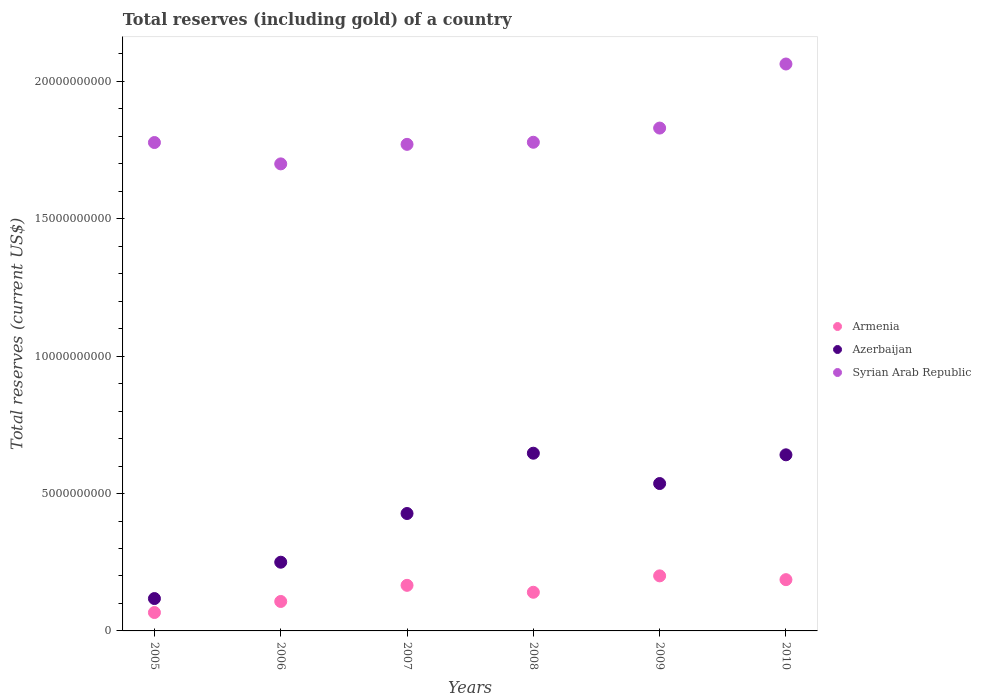Is the number of dotlines equal to the number of legend labels?
Provide a succinct answer. Yes. What is the total reserves (including gold) in Armenia in 2008?
Your answer should be very brief. 1.41e+09. Across all years, what is the maximum total reserves (including gold) in Armenia?
Keep it short and to the point. 2.00e+09. Across all years, what is the minimum total reserves (including gold) in Syrian Arab Republic?
Make the answer very short. 1.70e+1. In which year was the total reserves (including gold) in Azerbaijan maximum?
Offer a terse response. 2008. In which year was the total reserves (including gold) in Armenia minimum?
Provide a succinct answer. 2005. What is the total total reserves (including gold) in Azerbaijan in the graph?
Keep it short and to the point. 2.62e+1. What is the difference between the total reserves (including gold) in Armenia in 2005 and that in 2006?
Provide a short and direct response. -4.02e+08. What is the difference between the total reserves (including gold) in Syrian Arab Republic in 2006 and the total reserves (including gold) in Armenia in 2005?
Keep it short and to the point. 1.63e+1. What is the average total reserves (including gold) in Azerbaijan per year?
Make the answer very short. 4.37e+09. In the year 2008, what is the difference between the total reserves (including gold) in Armenia and total reserves (including gold) in Syrian Arab Republic?
Keep it short and to the point. -1.64e+1. In how many years, is the total reserves (including gold) in Armenia greater than 7000000000 US$?
Ensure brevity in your answer.  0. What is the ratio of the total reserves (including gold) in Azerbaijan in 2005 to that in 2008?
Offer a very short reply. 0.18. Is the total reserves (including gold) in Armenia in 2007 less than that in 2009?
Ensure brevity in your answer.  Yes. Is the difference between the total reserves (including gold) in Armenia in 2006 and 2010 greater than the difference between the total reserves (including gold) in Syrian Arab Republic in 2006 and 2010?
Your answer should be compact. Yes. What is the difference between the highest and the second highest total reserves (including gold) in Armenia?
Provide a short and direct response. 1.38e+08. What is the difference between the highest and the lowest total reserves (including gold) in Armenia?
Keep it short and to the point. 1.33e+09. Does the total reserves (including gold) in Syrian Arab Republic monotonically increase over the years?
Keep it short and to the point. No. What is the difference between two consecutive major ticks on the Y-axis?
Keep it short and to the point. 5.00e+09. Are the values on the major ticks of Y-axis written in scientific E-notation?
Keep it short and to the point. No. How are the legend labels stacked?
Your answer should be very brief. Vertical. What is the title of the graph?
Ensure brevity in your answer.  Total reserves (including gold) of a country. What is the label or title of the Y-axis?
Your answer should be very brief. Total reserves (current US$). What is the Total reserves (current US$) of Armenia in 2005?
Make the answer very short. 6.69e+08. What is the Total reserves (current US$) of Azerbaijan in 2005?
Provide a short and direct response. 1.18e+09. What is the Total reserves (current US$) in Syrian Arab Republic in 2005?
Keep it short and to the point. 1.78e+1. What is the Total reserves (current US$) of Armenia in 2006?
Offer a terse response. 1.07e+09. What is the Total reserves (current US$) of Azerbaijan in 2006?
Your response must be concise. 2.50e+09. What is the Total reserves (current US$) of Syrian Arab Republic in 2006?
Provide a succinct answer. 1.70e+1. What is the Total reserves (current US$) of Armenia in 2007?
Your answer should be very brief. 1.66e+09. What is the Total reserves (current US$) of Azerbaijan in 2007?
Your response must be concise. 4.27e+09. What is the Total reserves (current US$) in Syrian Arab Republic in 2007?
Your response must be concise. 1.77e+1. What is the Total reserves (current US$) of Armenia in 2008?
Offer a very short reply. 1.41e+09. What is the Total reserves (current US$) of Azerbaijan in 2008?
Provide a short and direct response. 6.47e+09. What is the Total reserves (current US$) of Syrian Arab Republic in 2008?
Your answer should be very brief. 1.78e+1. What is the Total reserves (current US$) of Armenia in 2009?
Offer a terse response. 2.00e+09. What is the Total reserves (current US$) in Azerbaijan in 2009?
Offer a very short reply. 5.36e+09. What is the Total reserves (current US$) in Syrian Arab Republic in 2009?
Provide a short and direct response. 1.83e+1. What is the Total reserves (current US$) of Armenia in 2010?
Offer a very short reply. 1.87e+09. What is the Total reserves (current US$) in Azerbaijan in 2010?
Provide a short and direct response. 6.41e+09. What is the Total reserves (current US$) of Syrian Arab Republic in 2010?
Provide a short and direct response. 2.06e+1. Across all years, what is the maximum Total reserves (current US$) in Armenia?
Provide a succinct answer. 2.00e+09. Across all years, what is the maximum Total reserves (current US$) of Azerbaijan?
Offer a very short reply. 6.47e+09. Across all years, what is the maximum Total reserves (current US$) in Syrian Arab Republic?
Keep it short and to the point. 2.06e+1. Across all years, what is the minimum Total reserves (current US$) in Armenia?
Give a very brief answer. 6.69e+08. Across all years, what is the minimum Total reserves (current US$) in Azerbaijan?
Give a very brief answer. 1.18e+09. Across all years, what is the minimum Total reserves (current US$) in Syrian Arab Republic?
Keep it short and to the point. 1.70e+1. What is the total Total reserves (current US$) in Armenia in the graph?
Your answer should be compact. 8.68e+09. What is the total Total reserves (current US$) of Azerbaijan in the graph?
Keep it short and to the point. 2.62e+1. What is the total Total reserves (current US$) in Syrian Arab Republic in the graph?
Keep it short and to the point. 1.09e+11. What is the difference between the Total reserves (current US$) in Armenia in 2005 and that in 2006?
Provide a succinct answer. -4.02e+08. What is the difference between the Total reserves (current US$) in Azerbaijan in 2005 and that in 2006?
Your answer should be compact. -1.32e+09. What is the difference between the Total reserves (current US$) of Syrian Arab Republic in 2005 and that in 2006?
Offer a very short reply. 7.77e+08. What is the difference between the Total reserves (current US$) of Armenia in 2005 and that in 2007?
Provide a short and direct response. -9.90e+08. What is the difference between the Total reserves (current US$) in Azerbaijan in 2005 and that in 2007?
Your answer should be very brief. -3.10e+09. What is the difference between the Total reserves (current US$) in Syrian Arab Republic in 2005 and that in 2007?
Give a very brief answer. 6.67e+07. What is the difference between the Total reserves (current US$) in Armenia in 2005 and that in 2008?
Offer a very short reply. -7.37e+08. What is the difference between the Total reserves (current US$) of Azerbaijan in 2005 and that in 2008?
Ensure brevity in your answer.  -5.29e+09. What is the difference between the Total reserves (current US$) in Syrian Arab Republic in 2005 and that in 2008?
Provide a succinct answer. -9.60e+06. What is the difference between the Total reserves (current US$) of Armenia in 2005 and that in 2009?
Your answer should be very brief. -1.33e+09. What is the difference between the Total reserves (current US$) of Azerbaijan in 2005 and that in 2009?
Provide a succinct answer. -4.19e+09. What is the difference between the Total reserves (current US$) in Syrian Arab Republic in 2005 and that in 2009?
Ensure brevity in your answer.  -5.26e+08. What is the difference between the Total reserves (current US$) of Armenia in 2005 and that in 2010?
Keep it short and to the point. -1.20e+09. What is the difference between the Total reserves (current US$) in Azerbaijan in 2005 and that in 2010?
Give a very brief answer. -5.23e+09. What is the difference between the Total reserves (current US$) of Syrian Arab Republic in 2005 and that in 2010?
Ensure brevity in your answer.  -2.86e+09. What is the difference between the Total reserves (current US$) of Armenia in 2006 and that in 2007?
Give a very brief answer. -5.87e+08. What is the difference between the Total reserves (current US$) in Azerbaijan in 2006 and that in 2007?
Your answer should be very brief. -1.77e+09. What is the difference between the Total reserves (current US$) in Syrian Arab Republic in 2006 and that in 2007?
Ensure brevity in your answer.  -7.11e+08. What is the difference between the Total reserves (current US$) of Armenia in 2006 and that in 2008?
Provide a short and direct response. -3.35e+08. What is the difference between the Total reserves (current US$) of Azerbaijan in 2006 and that in 2008?
Make the answer very short. -3.97e+09. What is the difference between the Total reserves (current US$) of Syrian Arab Republic in 2006 and that in 2008?
Give a very brief answer. -7.87e+08. What is the difference between the Total reserves (current US$) of Armenia in 2006 and that in 2009?
Your answer should be very brief. -9.32e+08. What is the difference between the Total reserves (current US$) of Azerbaijan in 2006 and that in 2009?
Give a very brief answer. -2.86e+09. What is the difference between the Total reserves (current US$) of Syrian Arab Republic in 2006 and that in 2009?
Make the answer very short. -1.30e+09. What is the difference between the Total reserves (current US$) of Armenia in 2006 and that in 2010?
Offer a very short reply. -7.94e+08. What is the difference between the Total reserves (current US$) of Azerbaijan in 2006 and that in 2010?
Offer a terse response. -3.91e+09. What is the difference between the Total reserves (current US$) of Syrian Arab Republic in 2006 and that in 2010?
Your response must be concise. -3.64e+09. What is the difference between the Total reserves (current US$) in Armenia in 2007 and that in 2008?
Keep it short and to the point. 2.52e+08. What is the difference between the Total reserves (current US$) in Azerbaijan in 2007 and that in 2008?
Offer a terse response. -2.19e+09. What is the difference between the Total reserves (current US$) in Syrian Arab Republic in 2007 and that in 2008?
Provide a short and direct response. -7.63e+07. What is the difference between the Total reserves (current US$) in Armenia in 2007 and that in 2009?
Offer a terse response. -3.45e+08. What is the difference between the Total reserves (current US$) of Azerbaijan in 2007 and that in 2009?
Offer a terse response. -1.09e+09. What is the difference between the Total reserves (current US$) in Syrian Arab Republic in 2007 and that in 2009?
Your answer should be compact. -5.93e+08. What is the difference between the Total reserves (current US$) of Armenia in 2007 and that in 2010?
Provide a short and direct response. -2.07e+08. What is the difference between the Total reserves (current US$) of Azerbaijan in 2007 and that in 2010?
Offer a terse response. -2.14e+09. What is the difference between the Total reserves (current US$) of Syrian Arab Republic in 2007 and that in 2010?
Offer a terse response. -2.92e+09. What is the difference between the Total reserves (current US$) of Armenia in 2008 and that in 2009?
Keep it short and to the point. -5.97e+08. What is the difference between the Total reserves (current US$) of Azerbaijan in 2008 and that in 2009?
Provide a succinct answer. 1.10e+09. What is the difference between the Total reserves (current US$) in Syrian Arab Republic in 2008 and that in 2009?
Your answer should be compact. -5.17e+08. What is the difference between the Total reserves (current US$) of Armenia in 2008 and that in 2010?
Offer a terse response. -4.59e+08. What is the difference between the Total reserves (current US$) in Azerbaijan in 2008 and that in 2010?
Offer a very short reply. 5.82e+07. What is the difference between the Total reserves (current US$) of Syrian Arab Republic in 2008 and that in 2010?
Your answer should be very brief. -2.85e+09. What is the difference between the Total reserves (current US$) of Armenia in 2009 and that in 2010?
Provide a short and direct response. 1.38e+08. What is the difference between the Total reserves (current US$) of Azerbaijan in 2009 and that in 2010?
Your answer should be compact. -1.05e+09. What is the difference between the Total reserves (current US$) of Syrian Arab Republic in 2009 and that in 2010?
Provide a short and direct response. -2.33e+09. What is the difference between the Total reserves (current US$) in Armenia in 2005 and the Total reserves (current US$) in Azerbaijan in 2006?
Ensure brevity in your answer.  -1.83e+09. What is the difference between the Total reserves (current US$) of Armenia in 2005 and the Total reserves (current US$) of Syrian Arab Republic in 2006?
Make the answer very short. -1.63e+1. What is the difference between the Total reserves (current US$) of Azerbaijan in 2005 and the Total reserves (current US$) of Syrian Arab Republic in 2006?
Provide a short and direct response. -1.58e+1. What is the difference between the Total reserves (current US$) of Armenia in 2005 and the Total reserves (current US$) of Azerbaijan in 2007?
Provide a succinct answer. -3.60e+09. What is the difference between the Total reserves (current US$) in Armenia in 2005 and the Total reserves (current US$) in Syrian Arab Republic in 2007?
Offer a very short reply. -1.70e+1. What is the difference between the Total reserves (current US$) in Azerbaijan in 2005 and the Total reserves (current US$) in Syrian Arab Republic in 2007?
Offer a terse response. -1.65e+1. What is the difference between the Total reserves (current US$) of Armenia in 2005 and the Total reserves (current US$) of Azerbaijan in 2008?
Provide a succinct answer. -5.80e+09. What is the difference between the Total reserves (current US$) in Armenia in 2005 and the Total reserves (current US$) in Syrian Arab Republic in 2008?
Provide a short and direct response. -1.71e+1. What is the difference between the Total reserves (current US$) in Azerbaijan in 2005 and the Total reserves (current US$) in Syrian Arab Republic in 2008?
Provide a succinct answer. -1.66e+1. What is the difference between the Total reserves (current US$) of Armenia in 2005 and the Total reserves (current US$) of Azerbaijan in 2009?
Keep it short and to the point. -4.69e+09. What is the difference between the Total reserves (current US$) in Armenia in 2005 and the Total reserves (current US$) in Syrian Arab Republic in 2009?
Ensure brevity in your answer.  -1.76e+1. What is the difference between the Total reserves (current US$) of Azerbaijan in 2005 and the Total reserves (current US$) of Syrian Arab Republic in 2009?
Provide a succinct answer. -1.71e+1. What is the difference between the Total reserves (current US$) of Armenia in 2005 and the Total reserves (current US$) of Azerbaijan in 2010?
Offer a terse response. -5.74e+09. What is the difference between the Total reserves (current US$) in Armenia in 2005 and the Total reserves (current US$) in Syrian Arab Republic in 2010?
Your answer should be compact. -2.00e+1. What is the difference between the Total reserves (current US$) of Azerbaijan in 2005 and the Total reserves (current US$) of Syrian Arab Republic in 2010?
Provide a short and direct response. -1.95e+1. What is the difference between the Total reserves (current US$) in Armenia in 2006 and the Total reserves (current US$) in Azerbaijan in 2007?
Keep it short and to the point. -3.20e+09. What is the difference between the Total reserves (current US$) in Armenia in 2006 and the Total reserves (current US$) in Syrian Arab Republic in 2007?
Provide a short and direct response. -1.66e+1. What is the difference between the Total reserves (current US$) of Azerbaijan in 2006 and the Total reserves (current US$) of Syrian Arab Republic in 2007?
Provide a succinct answer. -1.52e+1. What is the difference between the Total reserves (current US$) in Armenia in 2006 and the Total reserves (current US$) in Azerbaijan in 2008?
Make the answer very short. -5.40e+09. What is the difference between the Total reserves (current US$) of Armenia in 2006 and the Total reserves (current US$) of Syrian Arab Republic in 2008?
Ensure brevity in your answer.  -1.67e+1. What is the difference between the Total reserves (current US$) in Azerbaijan in 2006 and the Total reserves (current US$) in Syrian Arab Republic in 2008?
Keep it short and to the point. -1.53e+1. What is the difference between the Total reserves (current US$) of Armenia in 2006 and the Total reserves (current US$) of Azerbaijan in 2009?
Keep it short and to the point. -4.29e+09. What is the difference between the Total reserves (current US$) of Armenia in 2006 and the Total reserves (current US$) of Syrian Arab Republic in 2009?
Provide a short and direct response. -1.72e+1. What is the difference between the Total reserves (current US$) in Azerbaijan in 2006 and the Total reserves (current US$) in Syrian Arab Republic in 2009?
Provide a succinct answer. -1.58e+1. What is the difference between the Total reserves (current US$) in Armenia in 2006 and the Total reserves (current US$) in Azerbaijan in 2010?
Give a very brief answer. -5.34e+09. What is the difference between the Total reserves (current US$) of Armenia in 2006 and the Total reserves (current US$) of Syrian Arab Republic in 2010?
Make the answer very short. -1.96e+1. What is the difference between the Total reserves (current US$) in Azerbaijan in 2006 and the Total reserves (current US$) in Syrian Arab Republic in 2010?
Provide a succinct answer. -1.81e+1. What is the difference between the Total reserves (current US$) of Armenia in 2007 and the Total reserves (current US$) of Azerbaijan in 2008?
Keep it short and to the point. -4.81e+09. What is the difference between the Total reserves (current US$) of Armenia in 2007 and the Total reserves (current US$) of Syrian Arab Republic in 2008?
Offer a very short reply. -1.61e+1. What is the difference between the Total reserves (current US$) in Azerbaijan in 2007 and the Total reserves (current US$) in Syrian Arab Republic in 2008?
Give a very brief answer. -1.35e+1. What is the difference between the Total reserves (current US$) in Armenia in 2007 and the Total reserves (current US$) in Azerbaijan in 2009?
Give a very brief answer. -3.70e+09. What is the difference between the Total reserves (current US$) in Armenia in 2007 and the Total reserves (current US$) in Syrian Arab Republic in 2009?
Your answer should be compact. -1.66e+1. What is the difference between the Total reserves (current US$) of Azerbaijan in 2007 and the Total reserves (current US$) of Syrian Arab Republic in 2009?
Ensure brevity in your answer.  -1.40e+1. What is the difference between the Total reserves (current US$) in Armenia in 2007 and the Total reserves (current US$) in Azerbaijan in 2010?
Give a very brief answer. -4.75e+09. What is the difference between the Total reserves (current US$) of Armenia in 2007 and the Total reserves (current US$) of Syrian Arab Republic in 2010?
Your answer should be very brief. -1.90e+1. What is the difference between the Total reserves (current US$) of Azerbaijan in 2007 and the Total reserves (current US$) of Syrian Arab Republic in 2010?
Provide a succinct answer. -1.64e+1. What is the difference between the Total reserves (current US$) of Armenia in 2008 and the Total reserves (current US$) of Azerbaijan in 2009?
Ensure brevity in your answer.  -3.96e+09. What is the difference between the Total reserves (current US$) in Armenia in 2008 and the Total reserves (current US$) in Syrian Arab Republic in 2009?
Your response must be concise. -1.69e+1. What is the difference between the Total reserves (current US$) of Azerbaijan in 2008 and the Total reserves (current US$) of Syrian Arab Republic in 2009?
Give a very brief answer. -1.18e+1. What is the difference between the Total reserves (current US$) in Armenia in 2008 and the Total reserves (current US$) in Azerbaijan in 2010?
Provide a short and direct response. -5.00e+09. What is the difference between the Total reserves (current US$) in Armenia in 2008 and the Total reserves (current US$) in Syrian Arab Republic in 2010?
Your answer should be compact. -1.92e+1. What is the difference between the Total reserves (current US$) in Azerbaijan in 2008 and the Total reserves (current US$) in Syrian Arab Republic in 2010?
Your answer should be very brief. -1.42e+1. What is the difference between the Total reserves (current US$) of Armenia in 2009 and the Total reserves (current US$) of Azerbaijan in 2010?
Offer a very short reply. -4.41e+09. What is the difference between the Total reserves (current US$) in Armenia in 2009 and the Total reserves (current US$) in Syrian Arab Republic in 2010?
Offer a very short reply. -1.86e+1. What is the difference between the Total reserves (current US$) in Azerbaijan in 2009 and the Total reserves (current US$) in Syrian Arab Republic in 2010?
Your answer should be compact. -1.53e+1. What is the average Total reserves (current US$) of Armenia per year?
Give a very brief answer. 1.45e+09. What is the average Total reserves (current US$) of Azerbaijan per year?
Your response must be concise. 4.37e+09. What is the average Total reserves (current US$) of Syrian Arab Republic per year?
Give a very brief answer. 1.82e+1. In the year 2005, what is the difference between the Total reserves (current US$) in Armenia and Total reserves (current US$) in Azerbaijan?
Give a very brief answer. -5.08e+08. In the year 2005, what is the difference between the Total reserves (current US$) of Armenia and Total reserves (current US$) of Syrian Arab Republic?
Give a very brief answer. -1.71e+1. In the year 2005, what is the difference between the Total reserves (current US$) of Azerbaijan and Total reserves (current US$) of Syrian Arab Republic?
Your answer should be very brief. -1.66e+1. In the year 2006, what is the difference between the Total reserves (current US$) in Armenia and Total reserves (current US$) in Azerbaijan?
Ensure brevity in your answer.  -1.43e+09. In the year 2006, what is the difference between the Total reserves (current US$) in Armenia and Total reserves (current US$) in Syrian Arab Republic?
Provide a short and direct response. -1.59e+1. In the year 2006, what is the difference between the Total reserves (current US$) of Azerbaijan and Total reserves (current US$) of Syrian Arab Republic?
Provide a succinct answer. -1.45e+1. In the year 2007, what is the difference between the Total reserves (current US$) of Armenia and Total reserves (current US$) of Azerbaijan?
Your answer should be very brief. -2.61e+09. In the year 2007, what is the difference between the Total reserves (current US$) of Armenia and Total reserves (current US$) of Syrian Arab Republic?
Ensure brevity in your answer.  -1.60e+1. In the year 2007, what is the difference between the Total reserves (current US$) of Azerbaijan and Total reserves (current US$) of Syrian Arab Republic?
Your answer should be compact. -1.34e+1. In the year 2008, what is the difference between the Total reserves (current US$) of Armenia and Total reserves (current US$) of Azerbaijan?
Your answer should be very brief. -5.06e+09. In the year 2008, what is the difference between the Total reserves (current US$) of Armenia and Total reserves (current US$) of Syrian Arab Republic?
Your answer should be compact. -1.64e+1. In the year 2008, what is the difference between the Total reserves (current US$) in Azerbaijan and Total reserves (current US$) in Syrian Arab Republic?
Your answer should be compact. -1.13e+1. In the year 2009, what is the difference between the Total reserves (current US$) of Armenia and Total reserves (current US$) of Azerbaijan?
Provide a succinct answer. -3.36e+09. In the year 2009, what is the difference between the Total reserves (current US$) of Armenia and Total reserves (current US$) of Syrian Arab Republic?
Your answer should be compact. -1.63e+1. In the year 2009, what is the difference between the Total reserves (current US$) of Azerbaijan and Total reserves (current US$) of Syrian Arab Republic?
Ensure brevity in your answer.  -1.29e+1. In the year 2010, what is the difference between the Total reserves (current US$) of Armenia and Total reserves (current US$) of Azerbaijan?
Your response must be concise. -4.54e+09. In the year 2010, what is the difference between the Total reserves (current US$) of Armenia and Total reserves (current US$) of Syrian Arab Republic?
Ensure brevity in your answer.  -1.88e+1. In the year 2010, what is the difference between the Total reserves (current US$) in Azerbaijan and Total reserves (current US$) in Syrian Arab Republic?
Your response must be concise. -1.42e+1. What is the ratio of the Total reserves (current US$) in Armenia in 2005 to that in 2006?
Make the answer very short. 0.62. What is the ratio of the Total reserves (current US$) in Azerbaijan in 2005 to that in 2006?
Your answer should be very brief. 0.47. What is the ratio of the Total reserves (current US$) in Syrian Arab Republic in 2005 to that in 2006?
Provide a short and direct response. 1.05. What is the ratio of the Total reserves (current US$) in Armenia in 2005 to that in 2007?
Provide a succinct answer. 0.4. What is the ratio of the Total reserves (current US$) in Azerbaijan in 2005 to that in 2007?
Offer a terse response. 0.28. What is the ratio of the Total reserves (current US$) of Armenia in 2005 to that in 2008?
Your answer should be compact. 0.48. What is the ratio of the Total reserves (current US$) in Azerbaijan in 2005 to that in 2008?
Provide a succinct answer. 0.18. What is the ratio of the Total reserves (current US$) of Armenia in 2005 to that in 2009?
Ensure brevity in your answer.  0.33. What is the ratio of the Total reserves (current US$) in Azerbaijan in 2005 to that in 2009?
Offer a very short reply. 0.22. What is the ratio of the Total reserves (current US$) of Syrian Arab Republic in 2005 to that in 2009?
Offer a terse response. 0.97. What is the ratio of the Total reserves (current US$) in Armenia in 2005 to that in 2010?
Ensure brevity in your answer.  0.36. What is the ratio of the Total reserves (current US$) of Azerbaijan in 2005 to that in 2010?
Keep it short and to the point. 0.18. What is the ratio of the Total reserves (current US$) in Syrian Arab Republic in 2005 to that in 2010?
Offer a terse response. 0.86. What is the ratio of the Total reserves (current US$) in Armenia in 2006 to that in 2007?
Provide a short and direct response. 0.65. What is the ratio of the Total reserves (current US$) in Azerbaijan in 2006 to that in 2007?
Provide a short and direct response. 0.59. What is the ratio of the Total reserves (current US$) of Syrian Arab Republic in 2006 to that in 2007?
Keep it short and to the point. 0.96. What is the ratio of the Total reserves (current US$) of Armenia in 2006 to that in 2008?
Ensure brevity in your answer.  0.76. What is the ratio of the Total reserves (current US$) of Azerbaijan in 2006 to that in 2008?
Keep it short and to the point. 0.39. What is the ratio of the Total reserves (current US$) of Syrian Arab Republic in 2006 to that in 2008?
Give a very brief answer. 0.96. What is the ratio of the Total reserves (current US$) of Armenia in 2006 to that in 2009?
Give a very brief answer. 0.54. What is the ratio of the Total reserves (current US$) of Azerbaijan in 2006 to that in 2009?
Give a very brief answer. 0.47. What is the ratio of the Total reserves (current US$) of Syrian Arab Republic in 2006 to that in 2009?
Keep it short and to the point. 0.93. What is the ratio of the Total reserves (current US$) in Armenia in 2006 to that in 2010?
Your answer should be very brief. 0.57. What is the ratio of the Total reserves (current US$) in Azerbaijan in 2006 to that in 2010?
Keep it short and to the point. 0.39. What is the ratio of the Total reserves (current US$) of Syrian Arab Republic in 2006 to that in 2010?
Your response must be concise. 0.82. What is the ratio of the Total reserves (current US$) in Armenia in 2007 to that in 2008?
Keep it short and to the point. 1.18. What is the ratio of the Total reserves (current US$) in Azerbaijan in 2007 to that in 2008?
Your response must be concise. 0.66. What is the ratio of the Total reserves (current US$) in Syrian Arab Republic in 2007 to that in 2008?
Your answer should be very brief. 1. What is the ratio of the Total reserves (current US$) in Armenia in 2007 to that in 2009?
Provide a short and direct response. 0.83. What is the ratio of the Total reserves (current US$) in Azerbaijan in 2007 to that in 2009?
Your response must be concise. 0.8. What is the ratio of the Total reserves (current US$) of Syrian Arab Republic in 2007 to that in 2009?
Your response must be concise. 0.97. What is the ratio of the Total reserves (current US$) in Armenia in 2007 to that in 2010?
Keep it short and to the point. 0.89. What is the ratio of the Total reserves (current US$) of Azerbaijan in 2007 to that in 2010?
Your answer should be compact. 0.67. What is the ratio of the Total reserves (current US$) in Syrian Arab Republic in 2007 to that in 2010?
Your response must be concise. 0.86. What is the ratio of the Total reserves (current US$) of Armenia in 2008 to that in 2009?
Your answer should be compact. 0.7. What is the ratio of the Total reserves (current US$) in Azerbaijan in 2008 to that in 2009?
Provide a short and direct response. 1.21. What is the ratio of the Total reserves (current US$) in Syrian Arab Republic in 2008 to that in 2009?
Offer a very short reply. 0.97. What is the ratio of the Total reserves (current US$) of Armenia in 2008 to that in 2010?
Your answer should be compact. 0.75. What is the ratio of the Total reserves (current US$) in Azerbaijan in 2008 to that in 2010?
Provide a succinct answer. 1.01. What is the ratio of the Total reserves (current US$) of Syrian Arab Republic in 2008 to that in 2010?
Your response must be concise. 0.86. What is the ratio of the Total reserves (current US$) in Armenia in 2009 to that in 2010?
Keep it short and to the point. 1.07. What is the ratio of the Total reserves (current US$) of Azerbaijan in 2009 to that in 2010?
Your response must be concise. 0.84. What is the ratio of the Total reserves (current US$) in Syrian Arab Republic in 2009 to that in 2010?
Your answer should be compact. 0.89. What is the difference between the highest and the second highest Total reserves (current US$) of Armenia?
Your answer should be very brief. 1.38e+08. What is the difference between the highest and the second highest Total reserves (current US$) in Azerbaijan?
Ensure brevity in your answer.  5.82e+07. What is the difference between the highest and the second highest Total reserves (current US$) in Syrian Arab Republic?
Keep it short and to the point. 2.33e+09. What is the difference between the highest and the lowest Total reserves (current US$) in Armenia?
Your response must be concise. 1.33e+09. What is the difference between the highest and the lowest Total reserves (current US$) in Azerbaijan?
Ensure brevity in your answer.  5.29e+09. What is the difference between the highest and the lowest Total reserves (current US$) of Syrian Arab Republic?
Your answer should be very brief. 3.64e+09. 